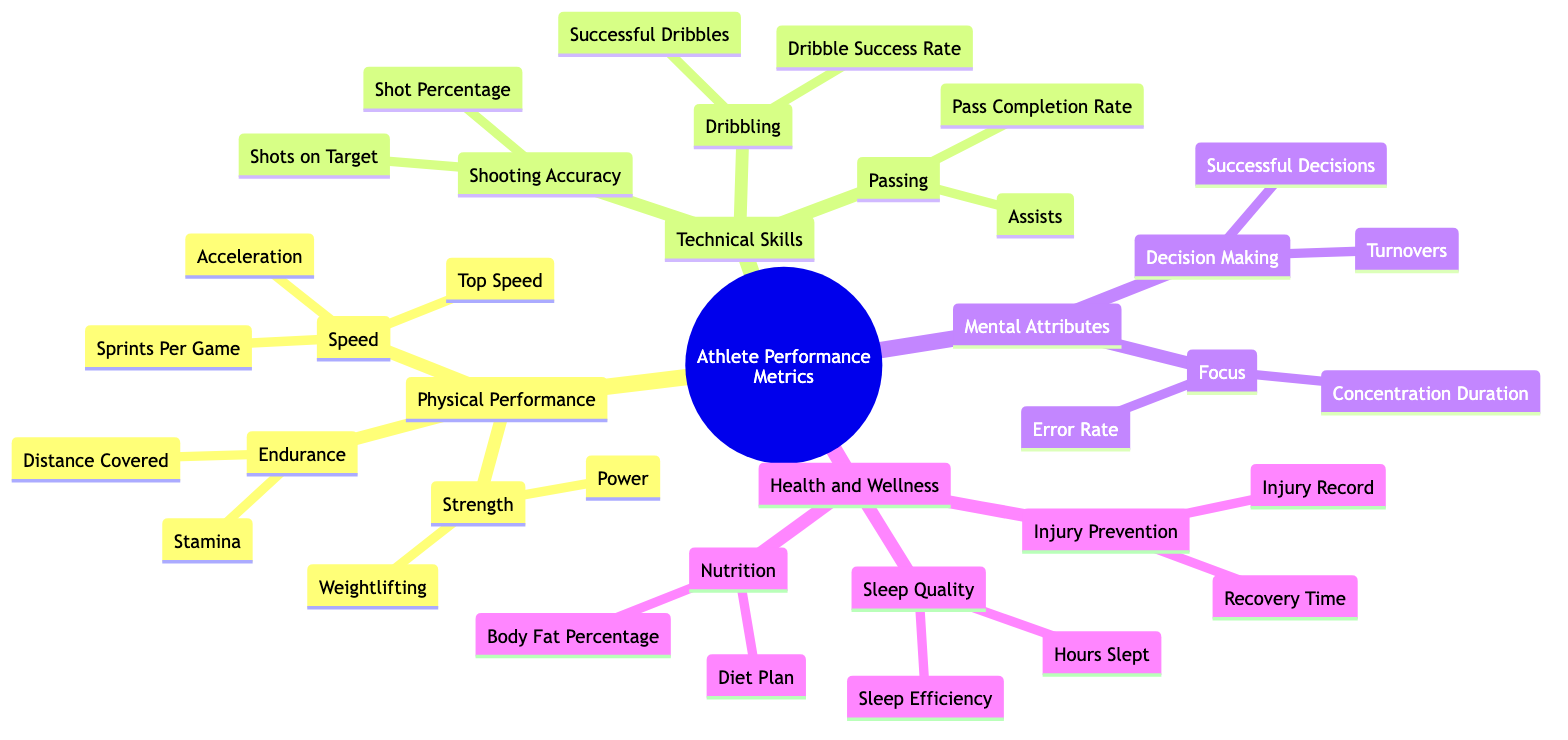What are the two main categories under Physical Performance? The "Physical Performance" section of the diagram has three subcategories: Speed, Endurance, and Strength. Thus, the two main categories would be Speed and Endurance.
Answer: Speed, Endurance How many metrics are listed under Technical Skills? In the "Technical Skills" section, there are three subcategories: Shooting Accuracy, Passing, and Dribbling. Each of these has its own metrics: Shooting Accuracy has 2, Passing has 2, and Dribbling has 2. This totals to 6 metrics.
Answer: 6 Which metric measures the number of successful dribbles? The "Successful Dribbles" metric is found in the "Dribbling" subcategory under "Technical Skills." It specifically tracks the number of successful dribbles a player makes during the game.
Answer: Successful Dribbles What are the components of Injury Prevention in Health and Wellness? Under the "Health and Wellness" category, the subcategory "Injury Prevention" has two components: Injury Record and Recovery Time. These two elements help track and manage player injuries.
Answer: Injury Record, Recovery Time Which metrics relate to decision-making in Mental Attributes? The "Decision Making" subcategory includes two key metrics: Successful Decisions and Turnovers. These metrics assess a player's ability to make correct decisions during play as well as the frequency of losing possession.
Answer: Successful Decisions, Turnovers What is the relationship between Endurance and the metrics listed under it? The "Endurance" subcategory contains two metrics: Distance Covered and Stamina. These metrics evaluate how well a player maintains performance and the total distance they cover in a game, which are both fundamental to assessing endurance.
Answer: Distance Covered, Stamina Which metric assesses sleeping patterns? The "Hours Slept" metric, found under "Sleep Quality" in the "Health and Wellness" category, specifically gauges the number of hours of sleep a player gets each night, thus assessing their sleeping patterns.
Answer: Hours Slept How many attributes are measured under Mental Attributes? The "Mental Attributes" section has two subcategories: Decision Making and Focus. Each of them has its own metrics, totaling 4 attributes being measured: Successful Decisions, Turnovers, Concentration Duration, and Error Rate.
Answer: 4 What is the purpose of the Diet Plan under Nutrition? The "Diet Plan" metric, under "Nutrition" in the "Health and Wellness" section, focuses on assessing a player's adherence to nutritional guidelines, which is essential for maintaining optimal performance and health.
Answer: Adherence to nutritional guidelines 